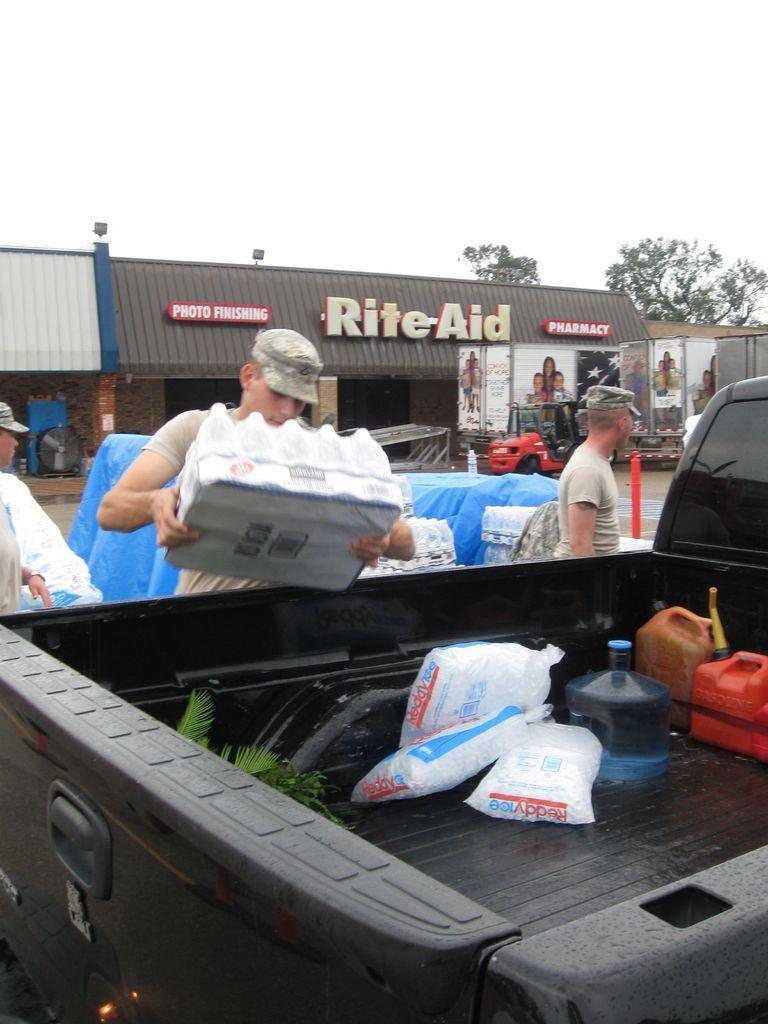Describe this image in one or two sentences. In this picture we can observe a person wearing a cap on his head, placing a box in a black color vehicle. There is another person beside the vehicle. We can observe blue color cover behind them. In the background there is a building with a brown color roof. We can observe trees and a sky. 